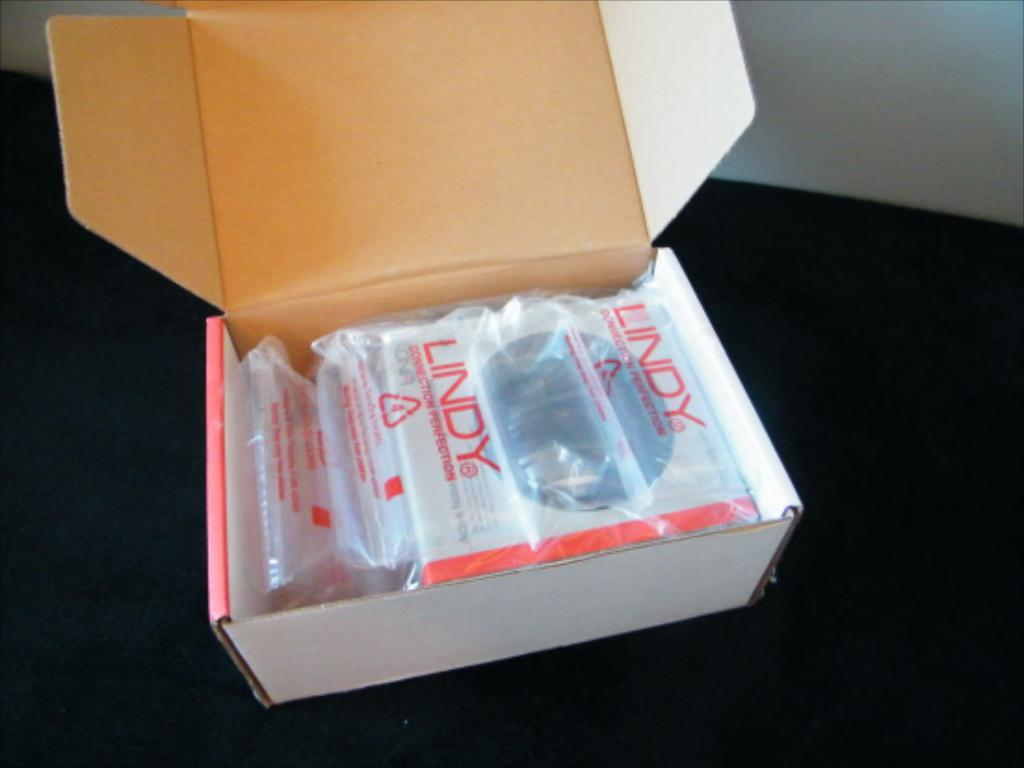<image>
Relay a brief, clear account of the picture shown. Lindy devices are in plastic wrappers and inside a white box. 